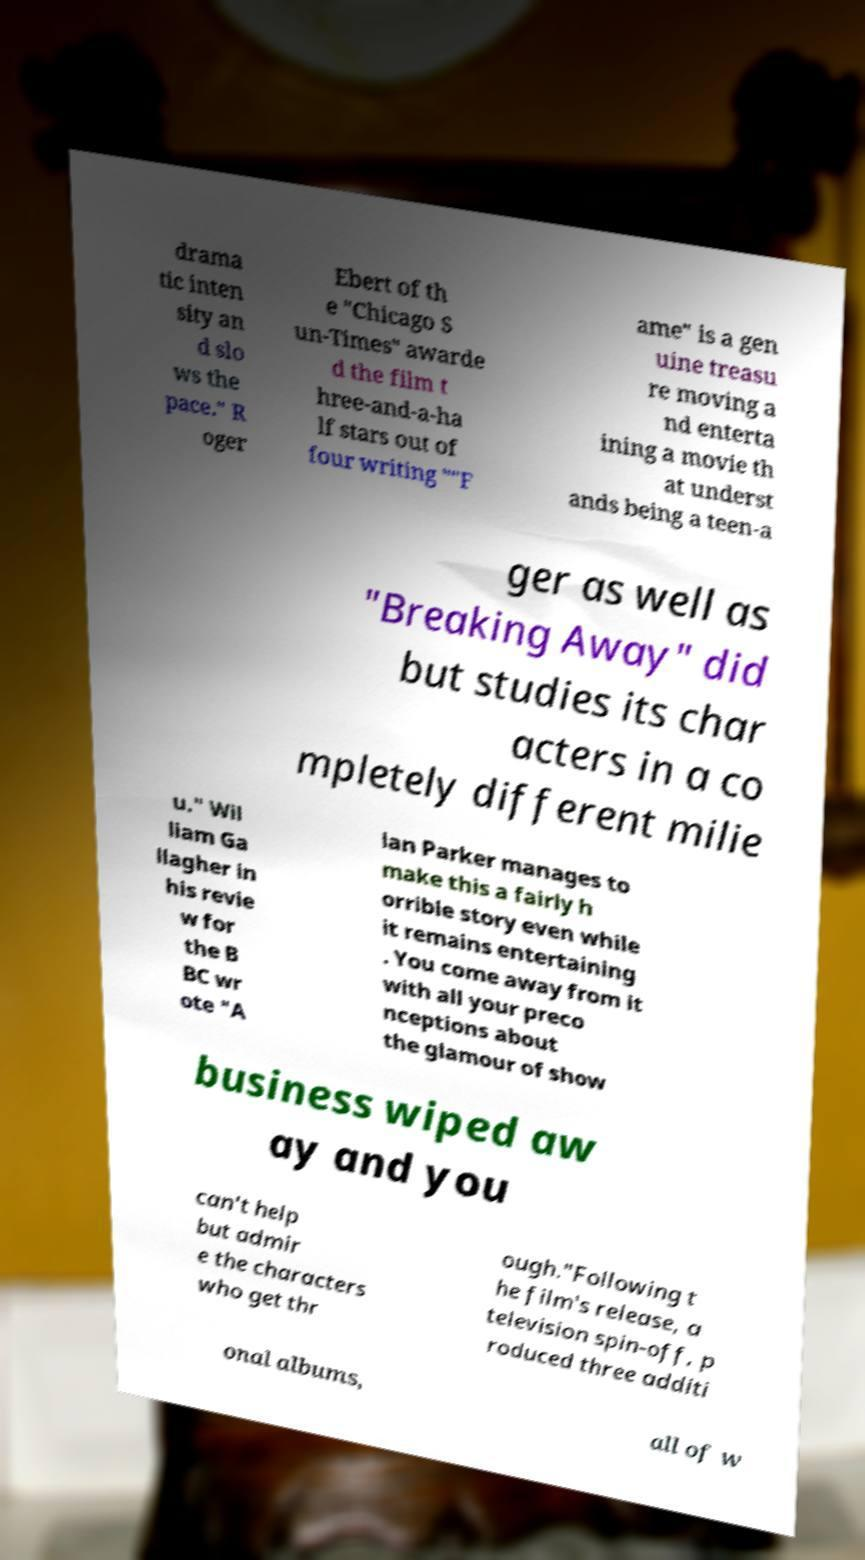Can you read and provide the text displayed in the image?This photo seems to have some interesting text. Can you extract and type it out for me? drama tic inten sity an d slo ws the pace." R oger Ebert of th e "Chicago S un-Times" awarde d the film t hree-and-a-ha lf stars out of four writing ""F ame" is a gen uine treasu re moving a nd enterta ining a movie th at underst ands being a teen-a ger as well as "Breaking Away" did but studies its char acters in a co mpletely different milie u." Wil liam Ga llagher in his revie w for the B BC wr ote "A lan Parker manages to make this a fairly h orrible story even while it remains entertaining . You come away from it with all your preco nceptions about the glamour of show business wiped aw ay and you can't help but admir e the characters who get thr ough."Following t he film's release, a television spin-off, p roduced three additi onal albums, all of w 